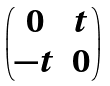Convert formula to latex. <formula><loc_0><loc_0><loc_500><loc_500>\begin{pmatrix} 0 & t \\ - t & 0 \end{pmatrix}</formula> 